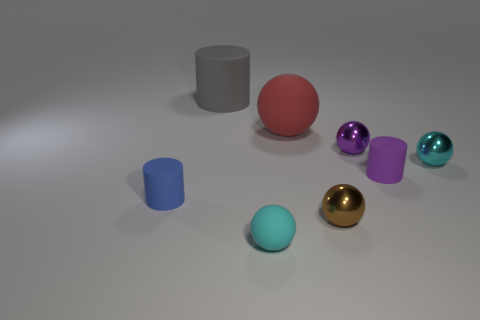Is the material of the small sphere left of the big matte sphere the same as the cylinder on the right side of the small brown shiny thing?
Keep it short and to the point. Yes. The brown object that is made of the same material as the purple sphere is what shape?
Your answer should be very brief. Sphere. Is there any other thing that has the same color as the small rubber sphere?
Provide a short and direct response. Yes. How many green cylinders are there?
Provide a short and direct response. 0. There is a matte object that is both behind the blue rubber object and in front of the large sphere; what shape is it?
Offer a very short reply. Cylinder. There is a small rubber object that is right of the brown shiny thing in front of the small cyan thing behind the purple cylinder; what is its shape?
Provide a short and direct response. Cylinder. What material is the cylinder that is both right of the blue rubber cylinder and in front of the big gray rubber cylinder?
Offer a very short reply. Rubber. How many cyan rubber balls are the same size as the gray cylinder?
Ensure brevity in your answer.  0. How many metallic objects are tiny purple spheres or balls?
Provide a succinct answer. 3. What is the material of the small purple ball?
Make the answer very short. Metal. 